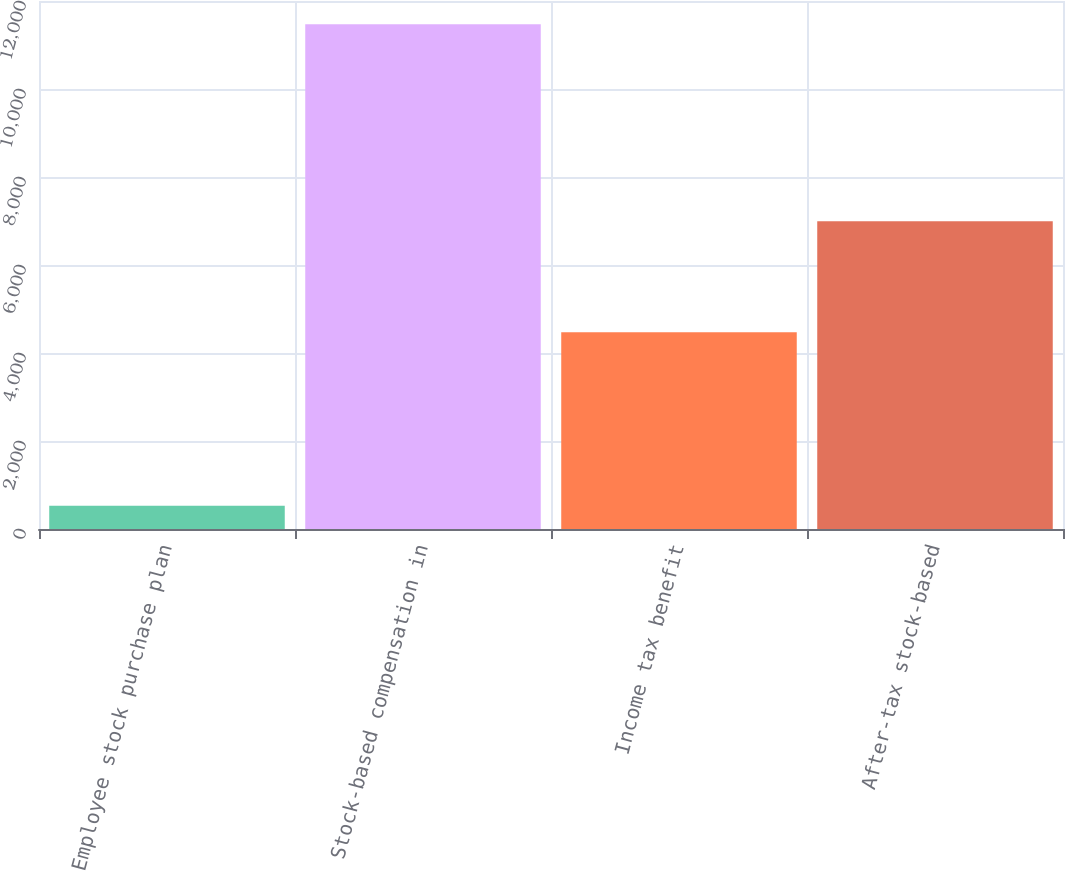<chart> <loc_0><loc_0><loc_500><loc_500><bar_chart><fcel>Employee stock purchase plan<fcel>Stock-based compensation in<fcel>Income tax benefit<fcel>After-tax stock-based<nl><fcel>530<fcel>11470<fcel>4473<fcel>6997<nl></chart> 